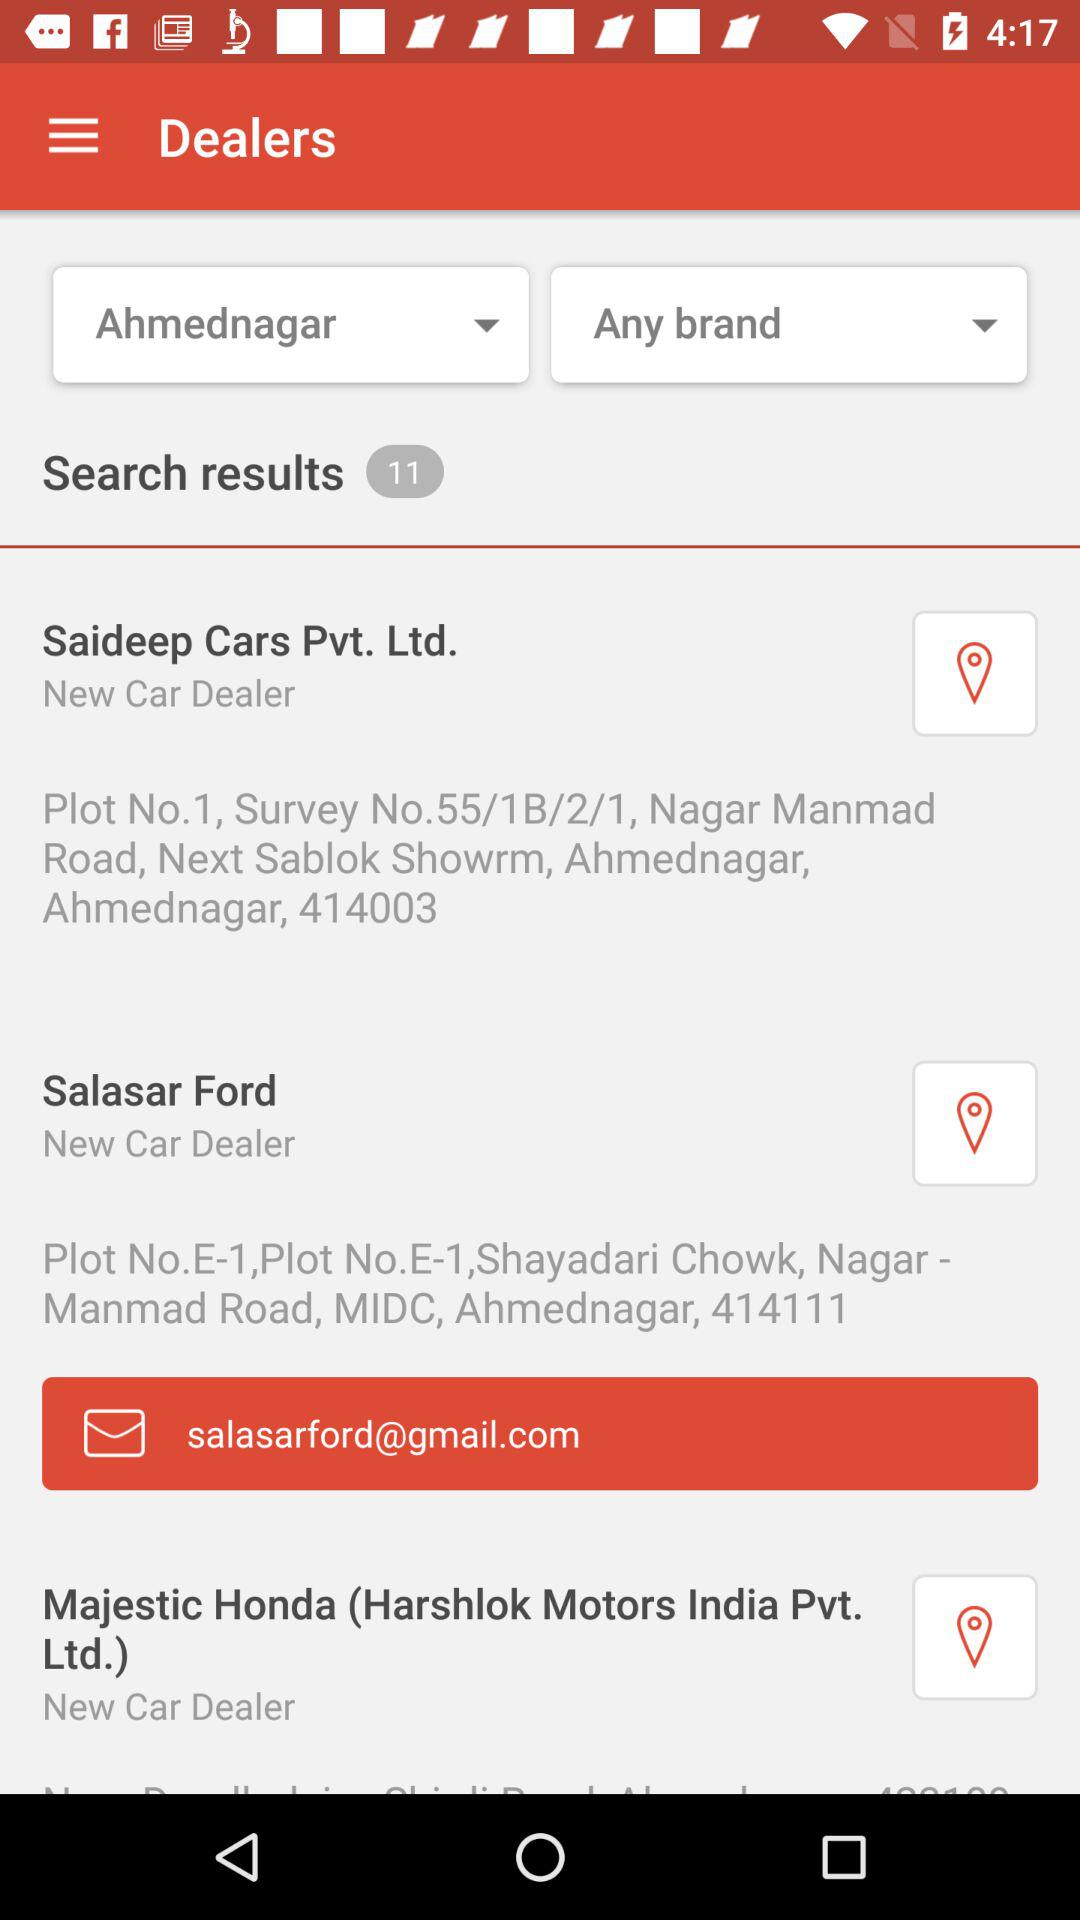What is the address of the "Saideep Cars Pvt. Ltd."? The address of the "Saideep Cars Pvt. Ltd." is Plot No. 1, Survey No. 55/1B/2/1, Nagar Manmad Road, Next Sablok Showroom, Ahmednagar, Ahmednagar, 414003. 